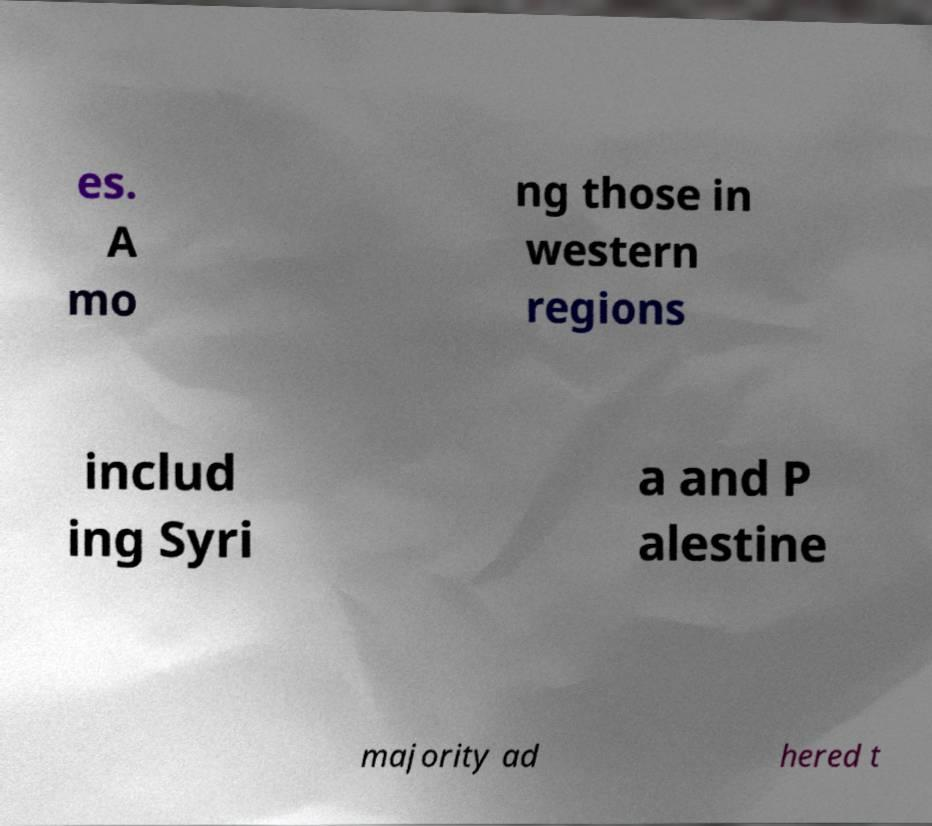What messages or text are displayed in this image? I need them in a readable, typed format. es. A mo ng those in western regions includ ing Syri a and P alestine majority ad hered t 